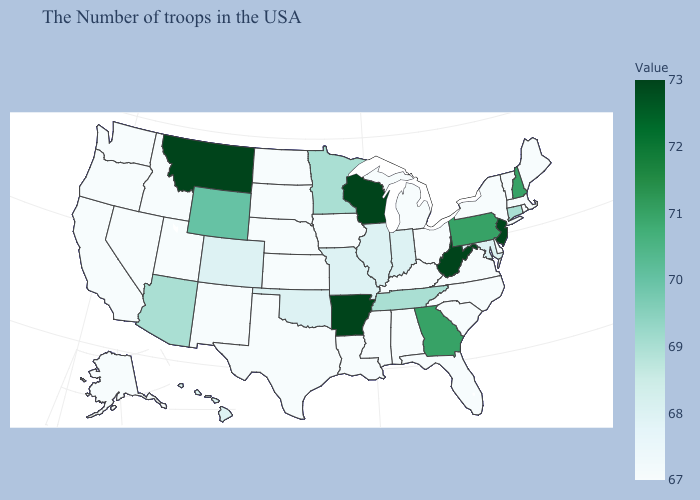Which states have the lowest value in the USA?
Answer briefly. Maine, Massachusetts, Rhode Island, Vermont, New York, Delaware, Virginia, North Carolina, South Carolina, Ohio, Florida, Michigan, Kentucky, Alabama, Mississippi, Louisiana, Iowa, Kansas, Nebraska, Texas, South Dakota, North Dakota, New Mexico, Utah, Idaho, Nevada, California, Washington, Oregon, Alaska. Which states hav the highest value in the South?
Be succinct. West Virginia, Arkansas. Among the states that border New Jersey , which have the highest value?
Quick response, please. Pennsylvania. Among the states that border California , which have the highest value?
Concise answer only. Arizona. Which states have the lowest value in the USA?
Write a very short answer. Maine, Massachusetts, Rhode Island, Vermont, New York, Delaware, Virginia, North Carolina, South Carolina, Ohio, Florida, Michigan, Kentucky, Alabama, Mississippi, Louisiana, Iowa, Kansas, Nebraska, Texas, South Dakota, North Dakota, New Mexico, Utah, Idaho, Nevada, California, Washington, Oregon, Alaska. Does South Dakota have the highest value in the USA?
Short answer required. No. 